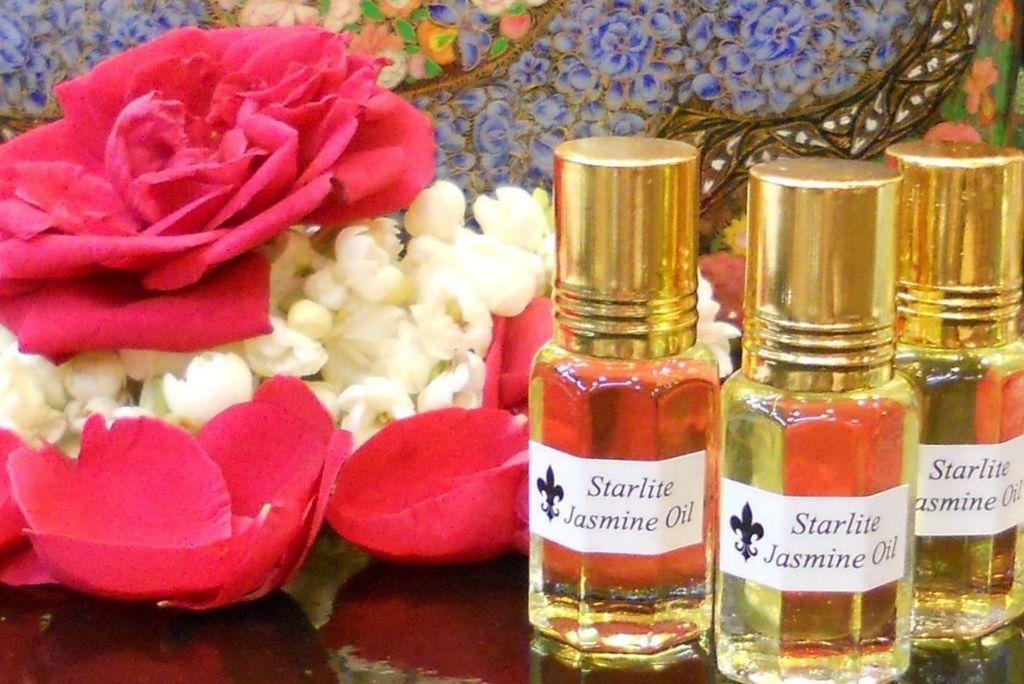<image>
Give a short and clear explanation of the subsequent image. some three colognes with starlite written on them 